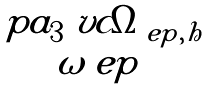Convert formula to latex. <formula><loc_0><loc_0><loc_500><loc_500>\begin{matrix} \ p a _ { 3 } \ v c \Omega _ { \ e p , h } \\ \omega _ { \ } e p \end{matrix}</formula> 